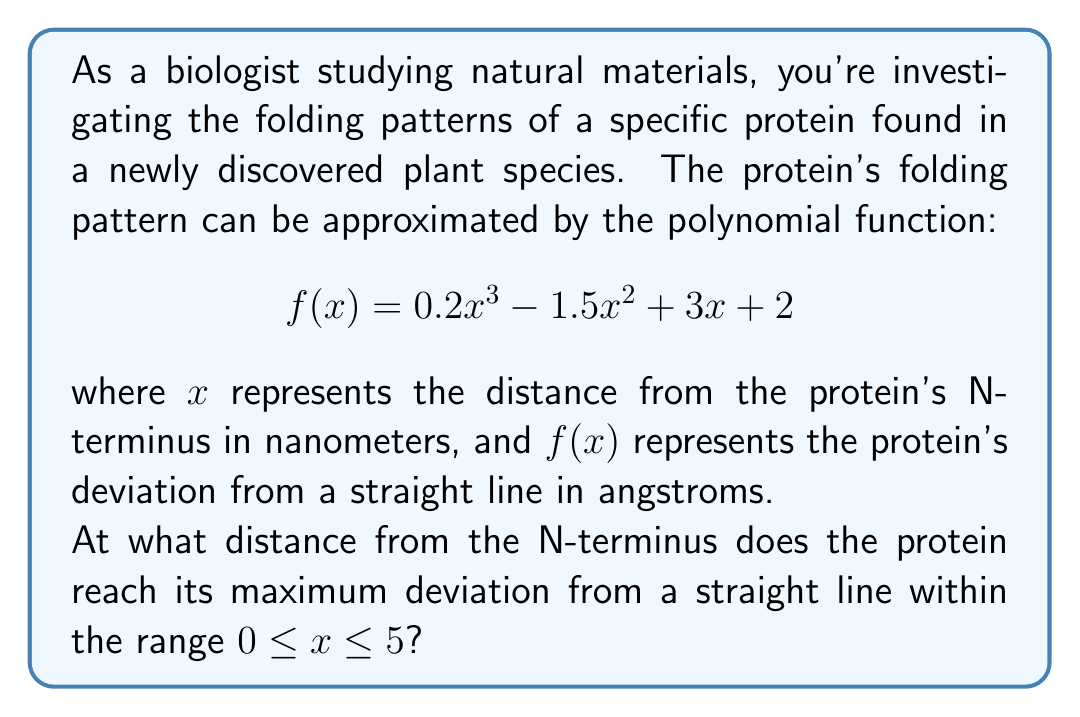Give your solution to this math problem. To find the maximum deviation of the protein folding pattern, we need to follow these steps:

1) First, we need to find the derivative of the function $f(x)$:
   $$f'(x) = 0.6x^2 - 3x + 3$$

2) To find the critical points, we set $f'(x) = 0$ and solve for $x$:
   $$0.6x^2 - 3x + 3 = 0$$

3) This is a quadratic equation. We can solve it using the quadratic formula:
   $$x = \frac{-b \pm \sqrt{b^2 - 4ac}}{2a}$$
   where $a = 0.6$, $b = -3$, and $c = 3$

4) Plugging in these values:
   $$x = \frac{3 \pm \sqrt{9 - 7.2}}{1.2} = \frac{3 \pm \sqrt{1.8}}{1.2}$$

5) Simplifying:
   $$x \approx 3.87 \text{ or } 1.29$$

6) Since we're looking at the range $0 \leq x \leq 5$, both of these critical points are within our range.

7) To determine which gives the maximum, we can either:
   a) Evaluate $f(x)$ at both points and at the endpoints of our range (0 and 5), or
   b) Use the second derivative test

8) Let's use method (a). Evaluating $f(x)$ at these points:
   $f(0) = 2$
   $f(1.29) \approx 3.95$
   $f(3.87) \approx 0.77$
   $f(5) = -5.5$

9) The maximum value occurs at $x \approx 1.29$
Answer: The protein reaches its maximum deviation from a straight line at approximately 1.29 nanometers from its N-terminus. 